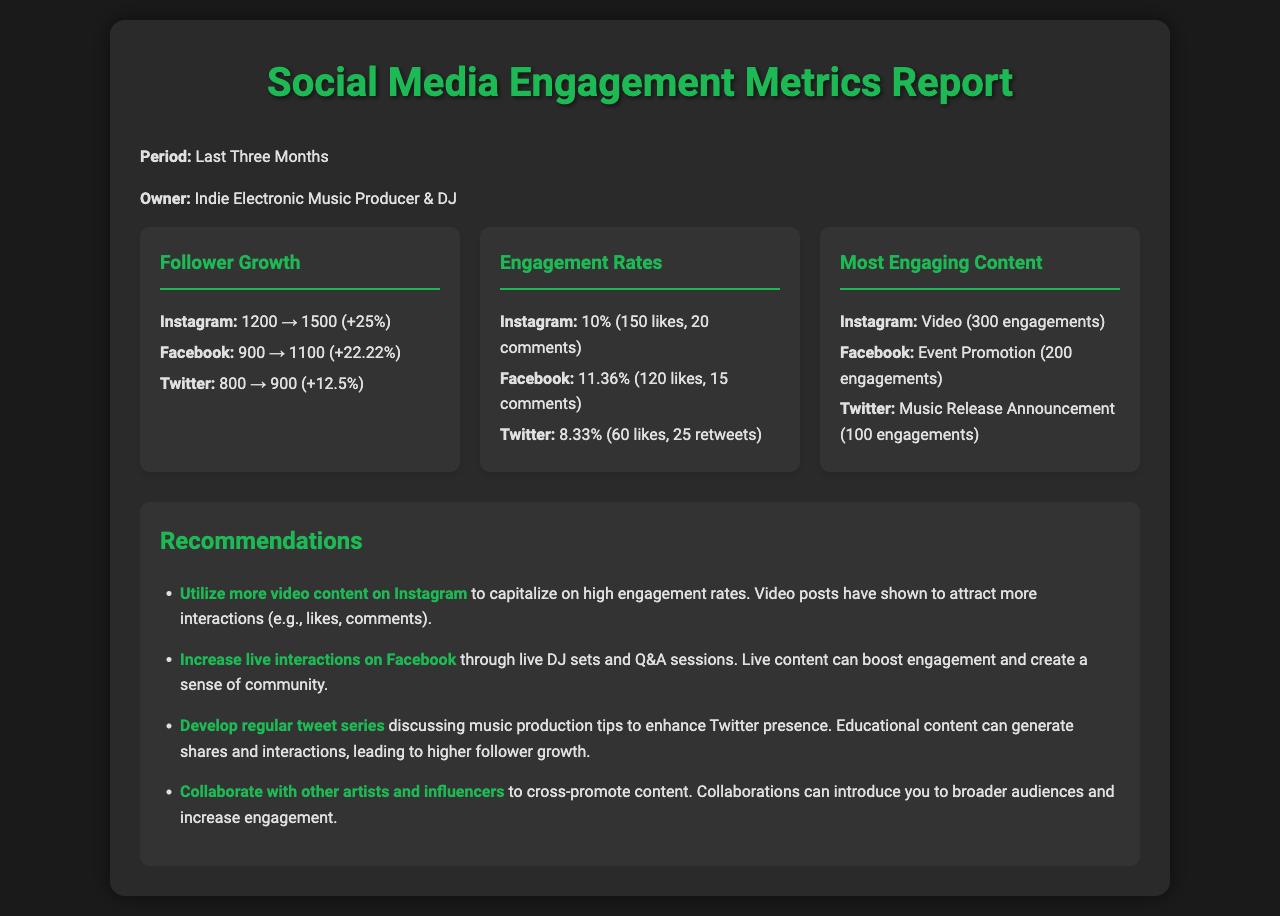What is the follower growth percentage on Instagram? The follower growth percentage for Instagram is calculated by comparing the number of followers from the start to the end of the period, which is 1200 to 1500, resulting in a 25% increase.
Answer: 25% What is the engagement rate on Facebook? The engagement rate on Facebook is indicated in the document as 11.36%, calculated from interactions like likes and comments in relation to total followers.
Answer: 11.36% What is the most engaging content on Twitter? The most engaging content on Twitter is identified in the report as the Music Release Announcement, which has 100 engagements.
Answer: Music Release Announcement What was the follower count on Facebook at the beginning of the period? The document states that the follower count on Facebook was 900 at the beginning of the period.
Answer: 900 What recommendation suggests using more video content? The recommendation to utilize more video content specifically on Instagram is highlighted in the document for enhancing engagement rates.
Answer: Utilize more video content on Instagram What type of post had the highest engagements on Instagram? According to the report, the type of post that had the highest engagements on Instagram was a Video with 300 engagements.
Answer: Video Which platform showed the least follower growth? By comparing the follower growth across the platforms, Twitter exhibited the least growth at 12.5%.
Answer: Twitter What is one of the recommendations for increasing engagement on Facebook? The document suggests increasing live interactions on Facebook through live DJ sets and Q&A sessions to boost engagement.
Answer: Increase live interactions on Facebook 